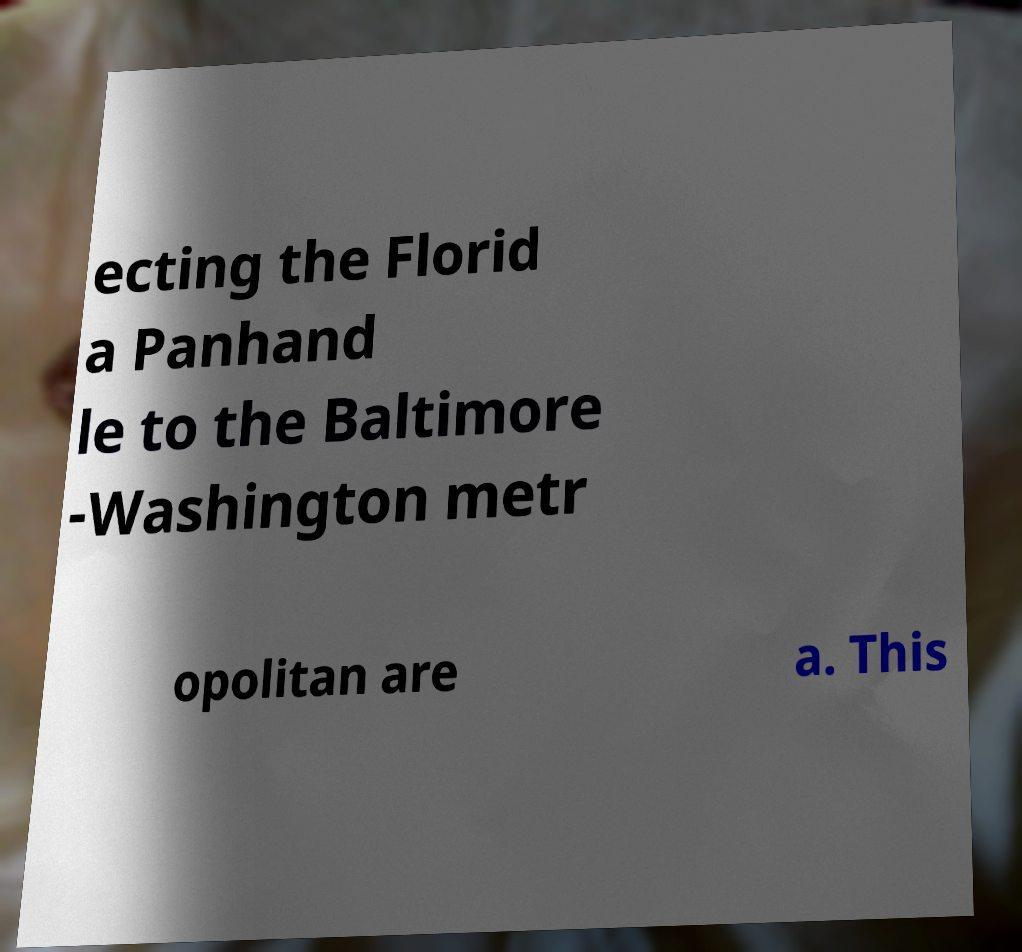Could you extract and type out the text from this image? ecting the Florid a Panhand le to the Baltimore -Washington metr opolitan are a. This 